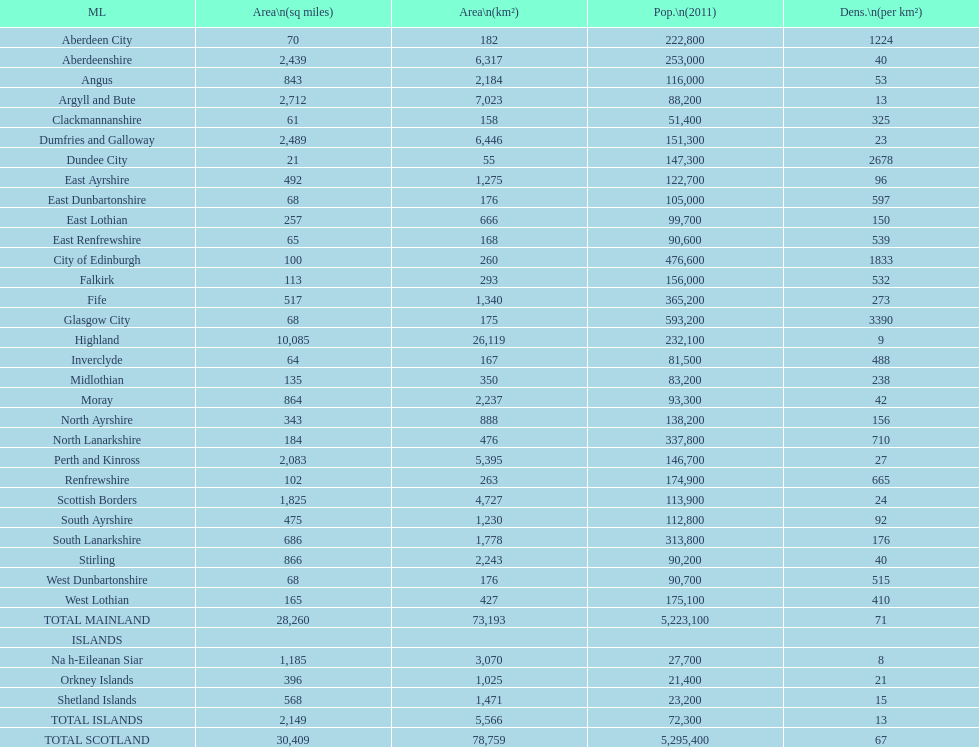If you were to arrange the locations from the smallest to largest area, which one would be first on the list? Dundee City. Would you be able to parse every entry in this table? {'header': ['ML', 'Area\\n(sq miles)', 'Area\\n(km²)', 'Pop.\\n(2011)', 'Dens.\\n(per km²)'], 'rows': [['Aberdeen City', '70', '182', '222,800', '1224'], ['Aberdeenshire', '2,439', '6,317', '253,000', '40'], ['Angus', '843', '2,184', '116,000', '53'], ['Argyll and Bute', '2,712', '7,023', '88,200', '13'], ['Clackmannanshire', '61', '158', '51,400', '325'], ['Dumfries and Galloway', '2,489', '6,446', '151,300', '23'], ['Dundee City', '21', '55', '147,300', '2678'], ['East Ayrshire', '492', '1,275', '122,700', '96'], ['East Dunbartonshire', '68', '176', '105,000', '597'], ['East Lothian', '257', '666', '99,700', '150'], ['East Renfrewshire', '65', '168', '90,600', '539'], ['City of Edinburgh', '100', '260', '476,600', '1833'], ['Falkirk', '113', '293', '156,000', '532'], ['Fife', '517', '1,340', '365,200', '273'], ['Glasgow City', '68', '175', '593,200', '3390'], ['Highland', '10,085', '26,119', '232,100', '9'], ['Inverclyde', '64', '167', '81,500', '488'], ['Midlothian', '135', '350', '83,200', '238'], ['Moray', '864', '2,237', '93,300', '42'], ['North Ayrshire', '343', '888', '138,200', '156'], ['North Lanarkshire', '184', '476', '337,800', '710'], ['Perth and Kinross', '2,083', '5,395', '146,700', '27'], ['Renfrewshire', '102', '263', '174,900', '665'], ['Scottish Borders', '1,825', '4,727', '113,900', '24'], ['South Ayrshire', '475', '1,230', '112,800', '92'], ['South Lanarkshire', '686', '1,778', '313,800', '176'], ['Stirling', '866', '2,243', '90,200', '40'], ['West Dunbartonshire', '68', '176', '90,700', '515'], ['West Lothian', '165', '427', '175,100', '410'], ['TOTAL MAINLAND', '28,260', '73,193', '5,223,100', '71'], ['ISLANDS', '', '', '', ''], ['Na h-Eileanan Siar', '1,185', '3,070', '27,700', '8'], ['Orkney Islands', '396', '1,025', '21,400', '21'], ['Shetland Islands', '568', '1,471', '23,200', '15'], ['TOTAL ISLANDS', '2,149', '5,566', '72,300', '13'], ['TOTAL SCOTLAND', '30,409', '78,759', '5,295,400', '67']]} 